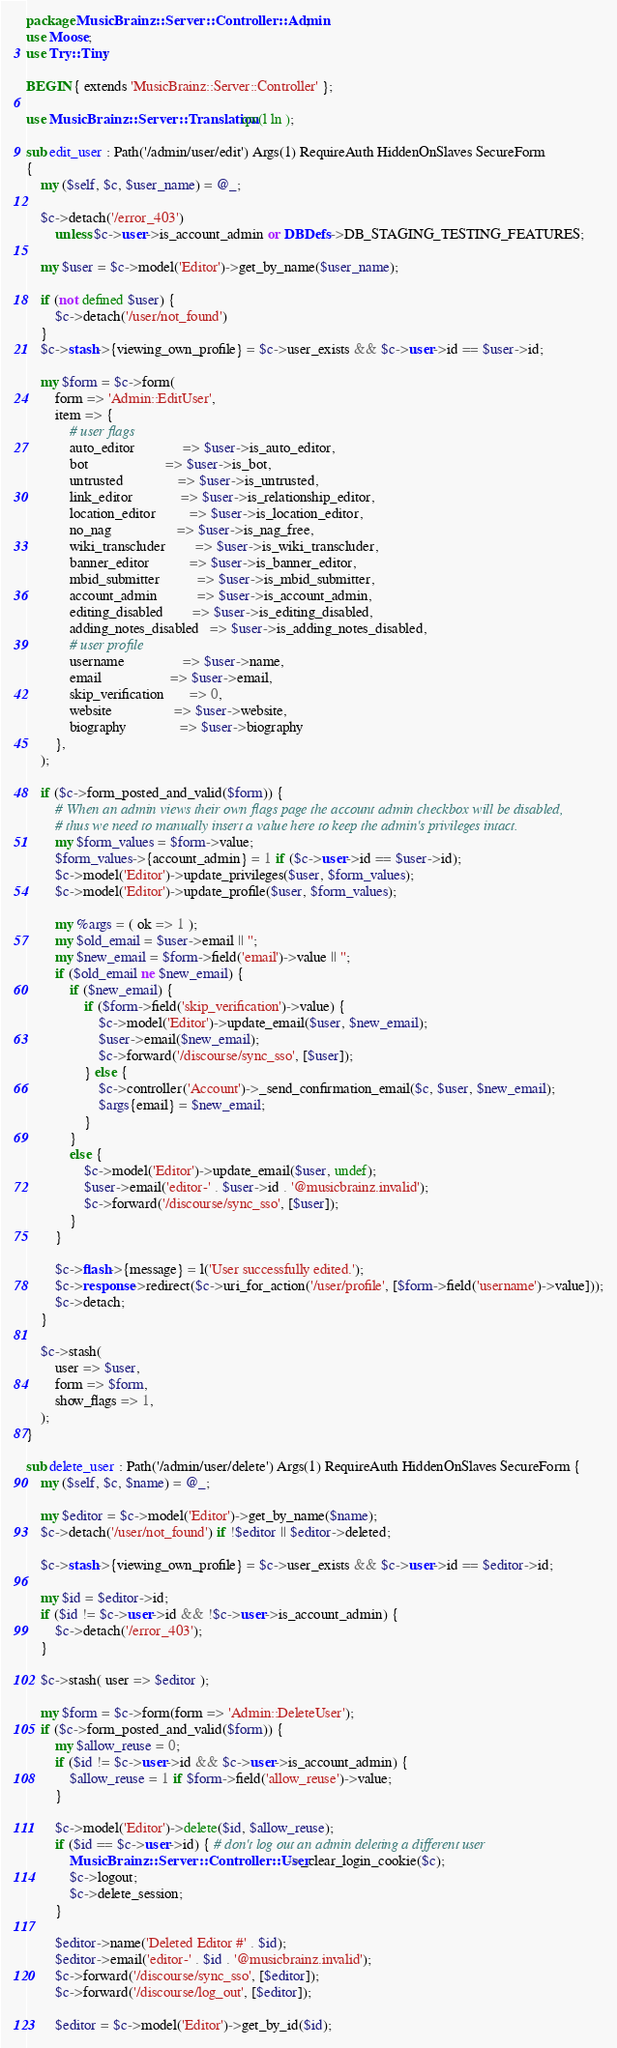Convert code to text. <code><loc_0><loc_0><loc_500><loc_500><_Perl_>package MusicBrainz::Server::Controller::Admin;
use Moose;
use Try::Tiny;

BEGIN { extends 'MusicBrainz::Server::Controller' };

use MusicBrainz::Server::Translation qw(l ln );

sub edit_user : Path('/admin/user/edit') Args(1) RequireAuth HiddenOnSlaves SecureForm
{
    my ($self, $c, $user_name) = @_;

    $c->detach('/error_403')
        unless $c->user->is_account_admin or DBDefs->DB_STAGING_TESTING_FEATURES;

    my $user = $c->model('Editor')->get_by_name($user_name);

    if (not defined $user) {
        $c->detach('/user/not_found')
    }
    $c->stash->{viewing_own_profile} = $c->user_exists && $c->user->id == $user->id;

    my $form = $c->form(
        form => 'Admin::EditUser',
        item => {
            # user flags
            auto_editor             => $user->is_auto_editor,
            bot                     => $user->is_bot,
            untrusted               => $user->is_untrusted,
            link_editor             => $user->is_relationship_editor,
            location_editor         => $user->is_location_editor,
            no_nag                  => $user->is_nag_free,
            wiki_transcluder        => $user->is_wiki_transcluder,
            banner_editor           => $user->is_banner_editor,
            mbid_submitter          => $user->is_mbid_submitter,
            account_admin           => $user->is_account_admin,
            editing_disabled        => $user->is_editing_disabled,
            adding_notes_disabled   => $user->is_adding_notes_disabled,
            # user profile
            username                => $user->name,
            email                   => $user->email,
            skip_verification       => 0,
            website                 => $user->website,
            biography               => $user->biography
        },
    );

    if ($c->form_posted_and_valid($form)) {
        # When an admin views their own flags page the account admin checkbox will be disabled,
        # thus we need to manually insert a value here to keep the admin's privileges intact.
        my $form_values = $form->value;
        $form_values->{account_admin} = 1 if ($c->user->id == $user->id);
        $c->model('Editor')->update_privileges($user, $form_values);
        $c->model('Editor')->update_profile($user, $form_values);

        my %args = ( ok => 1 );
        my $old_email = $user->email || '';
        my $new_email = $form->field('email')->value || '';
        if ($old_email ne $new_email) {
            if ($new_email) {
                if ($form->field('skip_verification')->value) {
                    $c->model('Editor')->update_email($user, $new_email);
                    $user->email($new_email);
                    $c->forward('/discourse/sync_sso', [$user]);
                } else {
                    $c->controller('Account')->_send_confirmation_email($c, $user, $new_email);
                    $args{email} = $new_email;
                }
            }
            else {
                $c->model('Editor')->update_email($user, undef);
                $user->email('editor-' . $user->id . '@musicbrainz.invalid');
                $c->forward('/discourse/sync_sso', [$user]);
            }
        }

        $c->flash->{message} = l('User successfully edited.');
        $c->response->redirect($c->uri_for_action('/user/profile', [$form->field('username')->value]));
        $c->detach;
    }

    $c->stash(
        user => $user,
        form => $form,
        show_flags => 1,
    );
}

sub delete_user : Path('/admin/user/delete') Args(1) RequireAuth HiddenOnSlaves SecureForm {
    my ($self, $c, $name) = @_;

    my $editor = $c->model('Editor')->get_by_name($name);
    $c->detach('/user/not_found') if !$editor || $editor->deleted;

    $c->stash->{viewing_own_profile} = $c->user_exists && $c->user->id == $editor->id;

    my $id = $editor->id;
    if ($id != $c->user->id && !$c->user->is_account_admin) {
        $c->detach('/error_403');
    }

    $c->stash( user => $editor );

    my $form = $c->form(form => 'Admin::DeleteUser');
    if ($c->form_posted_and_valid($form)) {
        my $allow_reuse = 0;
        if ($id != $c->user->id && $c->user->is_account_admin) {
            $allow_reuse = 1 if $form->field('allow_reuse')->value;
        }

        $c->model('Editor')->delete($id, $allow_reuse);
        if ($id == $c->user->id) { # don't log out an admin deleting a different user
            MusicBrainz::Server::Controller::User->_clear_login_cookie($c);
            $c->logout;
            $c->delete_session;
        }

        $editor->name('Deleted Editor #' . $id);
        $editor->email('editor-' . $id . '@musicbrainz.invalid');
        $c->forward('/discourse/sync_sso', [$editor]);
        $c->forward('/discourse/log_out', [$editor]);

        $editor = $c->model('Editor')->get_by_id($id);</code> 